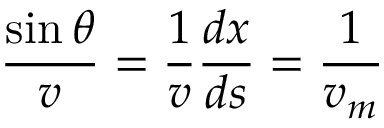<formula> <loc_0><loc_0><loc_500><loc_500>{ \frac { \sin { \theta } } { v } } = { \frac { 1 } { v } } { \frac { d x } { d s } } = { \frac { 1 } { v _ { m } } }</formula> 